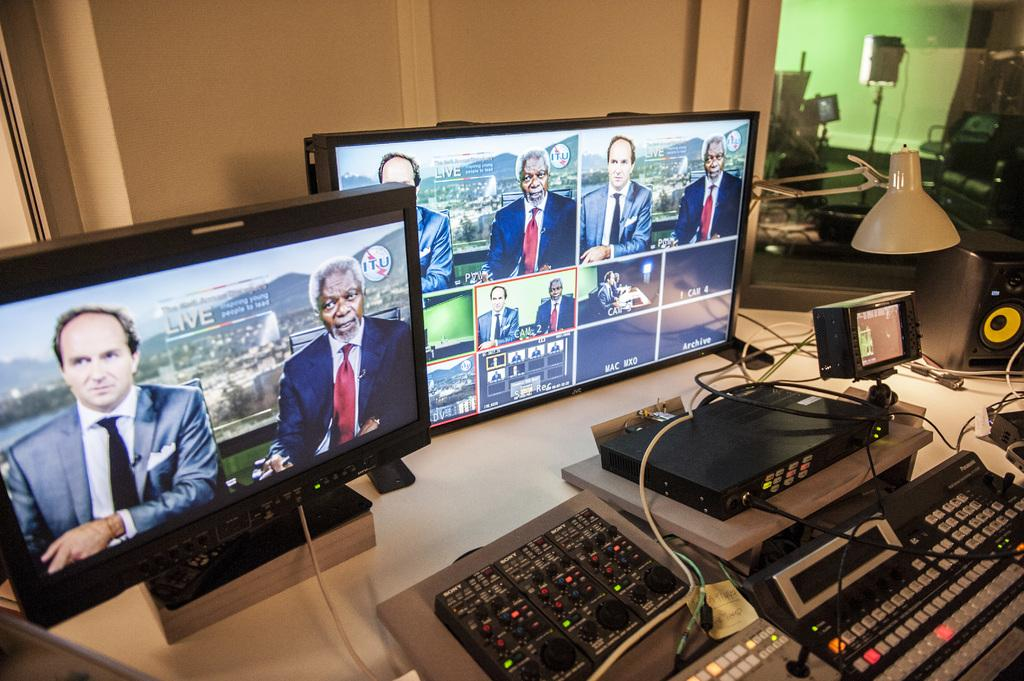<image>
Share a concise interpretation of the image provided. Two monitors showing a live report with two anchors. 